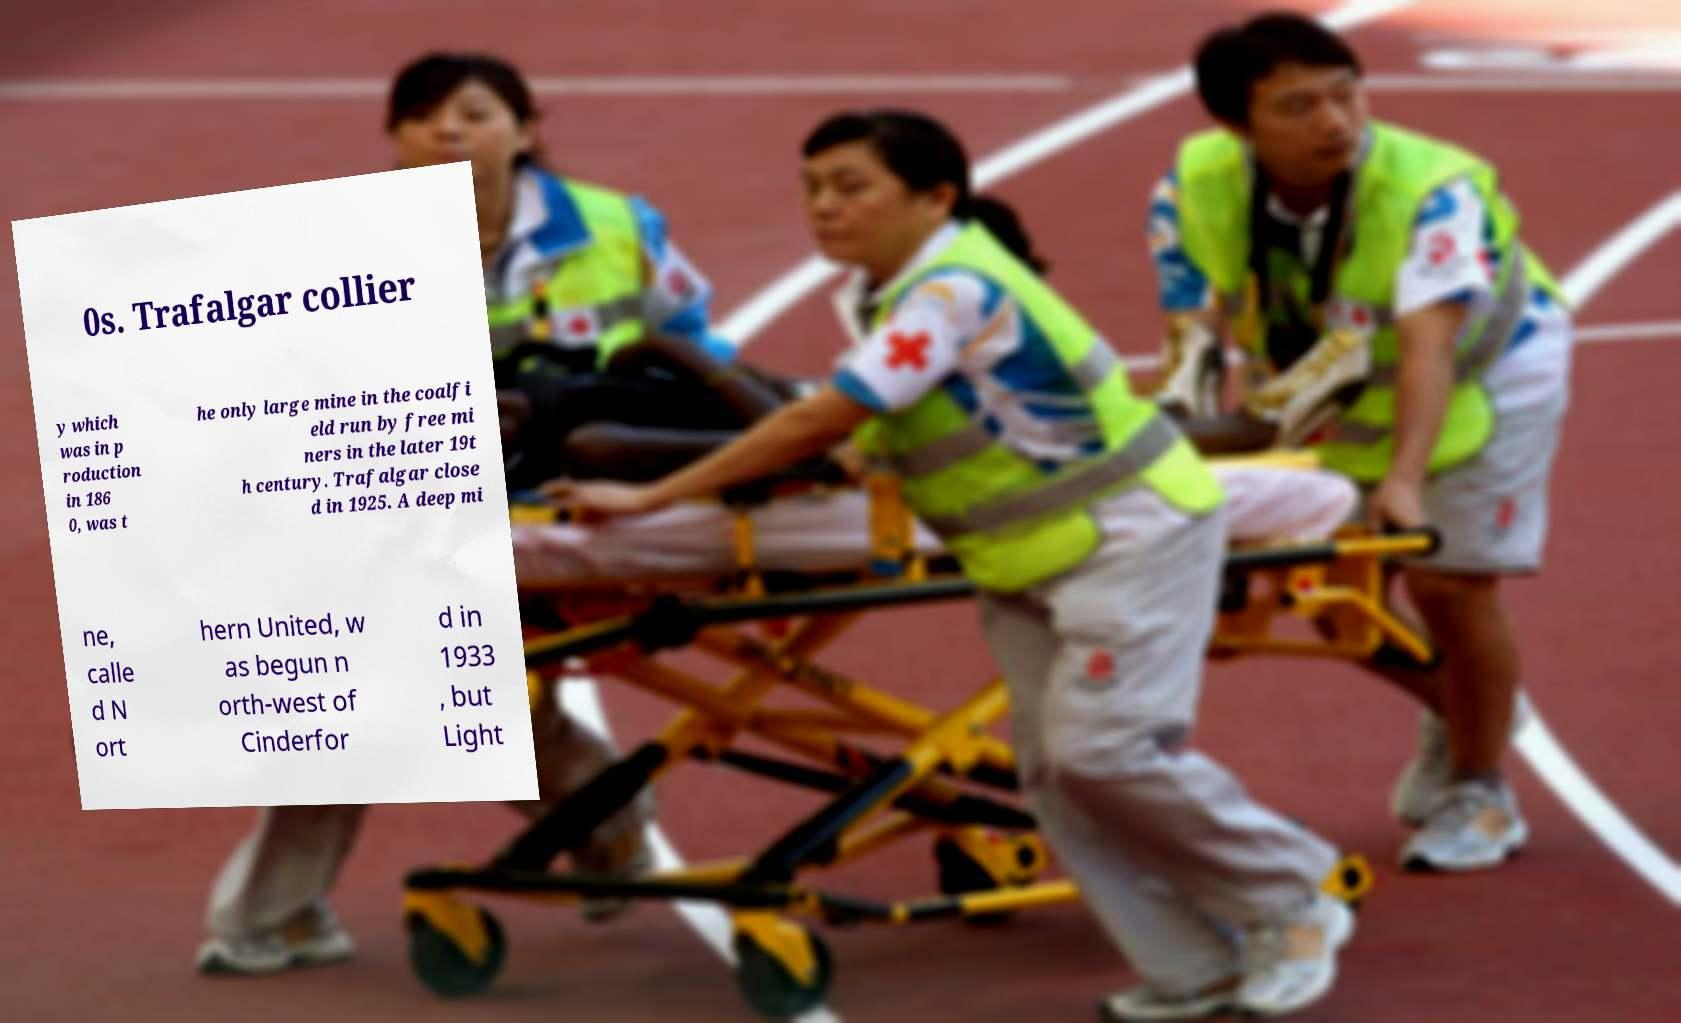Please read and relay the text visible in this image. What does it say? 0s. Trafalgar collier y which was in p roduction in 186 0, was t he only large mine in the coalfi eld run by free mi ners in the later 19t h century. Trafalgar close d in 1925. A deep mi ne, calle d N ort hern United, w as begun n orth-west of Cinderfor d in 1933 , but Light 